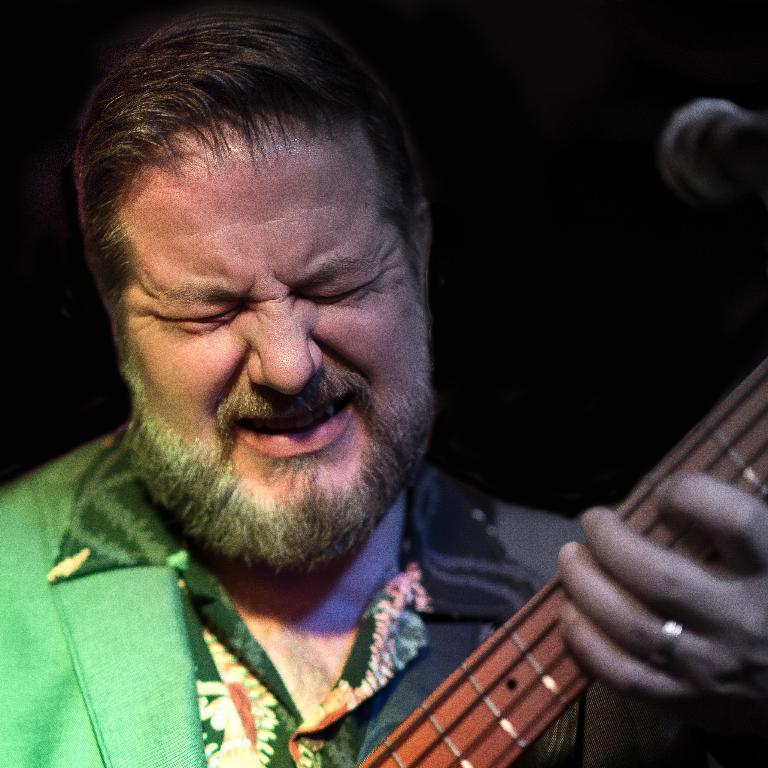Describe this image in one or two sentences. This is a picture of a man in green shirt. The man is holding the music instrument in front of the man there is a microphone. Background of this man is in black color. 